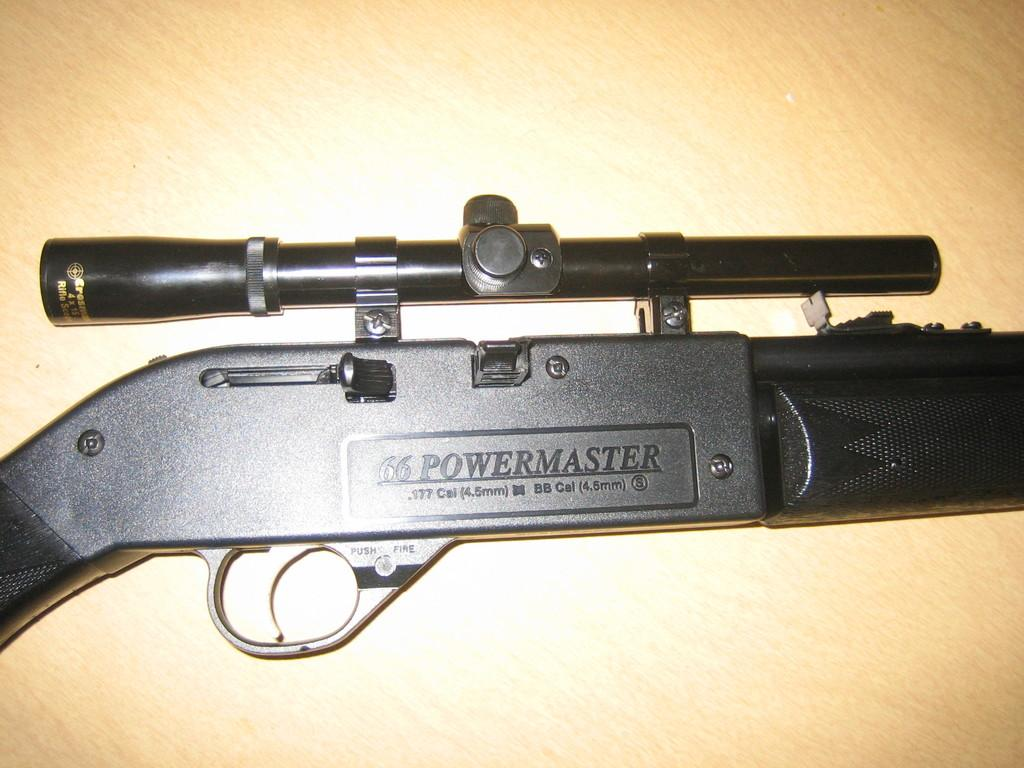What is the color of the gun in the image? The gun is black in color. Where is the playground located in the image? There is no playground present in the image; the only information provided is about the color of the gun. What type of jellyfish can be seen swimming in the image? There is no jellyfish present in the image; the only information provided is about the color of the gun. 